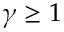Convert formula to latex. <formula><loc_0><loc_0><loc_500><loc_500>\gamma \geq 1</formula> 